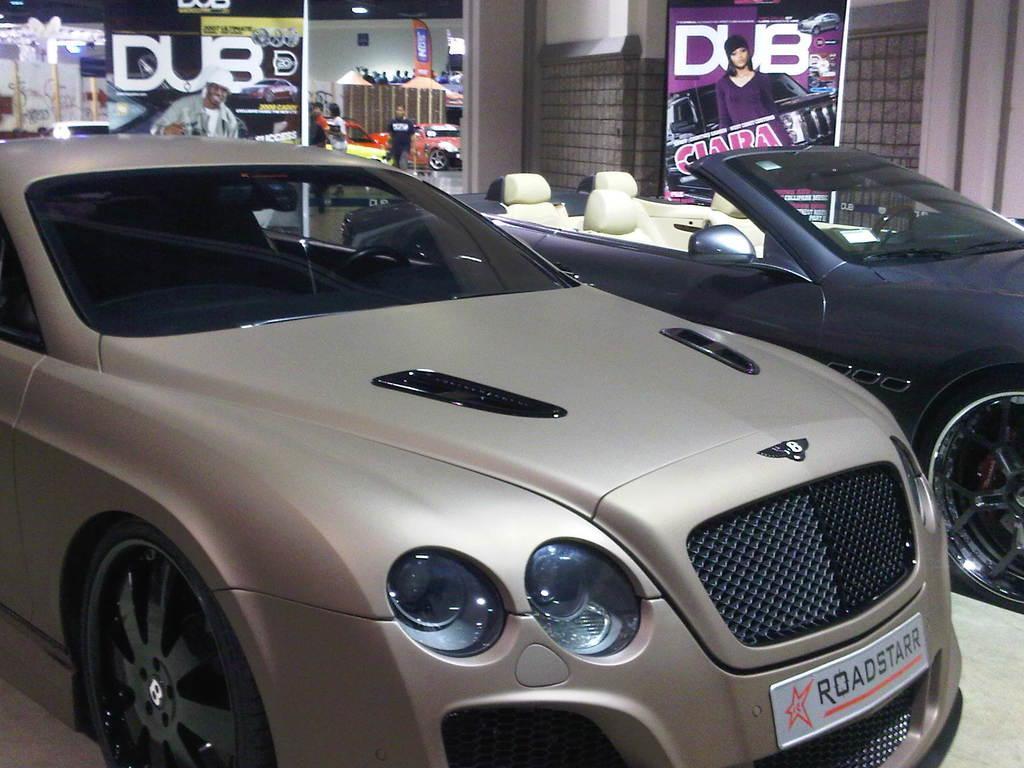In one or two sentences, can you explain what this image depicts? In the image we can see there are cars parked on the ground and there is a name plate on the car. It's written ¨ROAD STARR¨. Behind there are people standing and there are cars parked on the ground. There is a banner kept on the ground. 